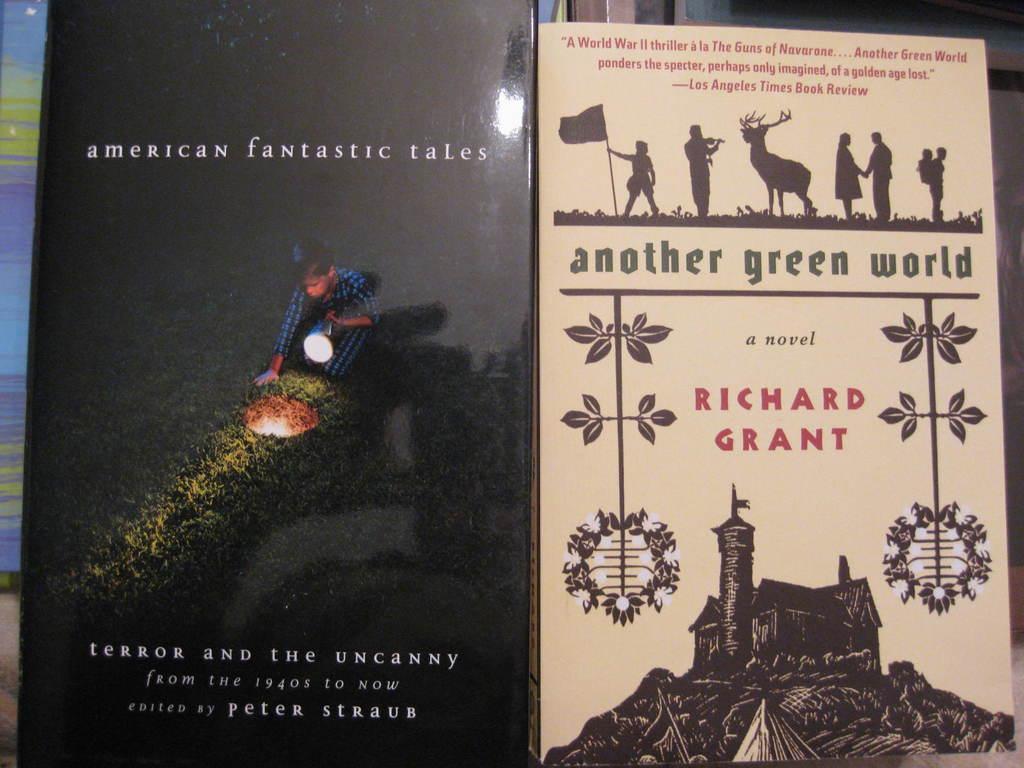Who is the author of the book?
Your answer should be compact. Richard grant. What is the name of the book?
Provide a short and direct response. Another green world. 